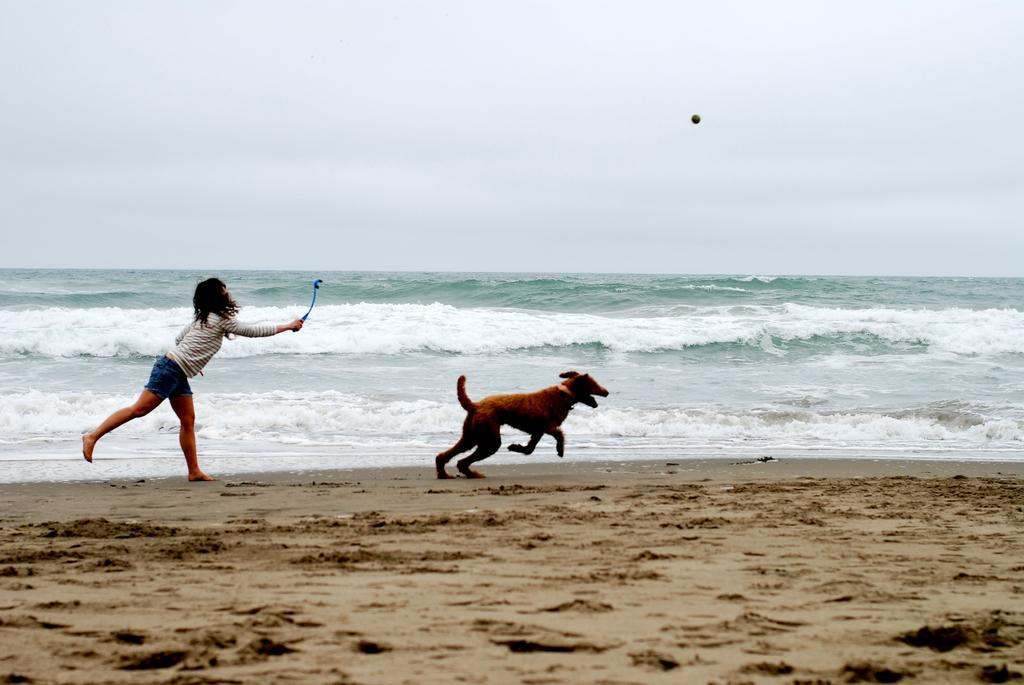Who is present in the image? There is a woman in the image. What is the woman wearing? The woman is wearing clothes. What is the woman holding in her hand? The woman is holding a stick in her hand. What is happening in the image? There is a dog running in the image, and it shows a beach. What can be seen in the sky? The sky is visible in the image. What type of grain is being harvested by the woman in the image? There is no grain present in the image; the woman is holding a stick and there is a dog running on a beach. 